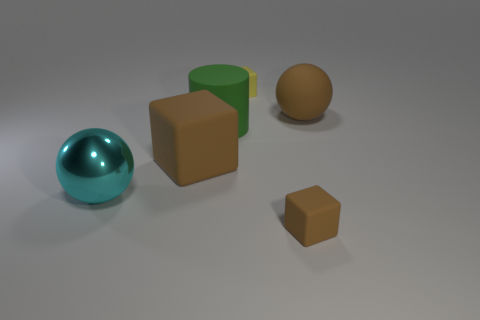What is the shape of the brown matte thing to the left of the tiny rubber cube that is behind the large sphere that is to the right of the tiny brown cube?
Provide a short and direct response. Cube. What number of things are big brown rubber objects to the left of the big green rubber cylinder or small cubes that are in front of the big cyan ball?
Provide a succinct answer. 2. There is a block that is behind the big brown rubber thing that is right of the large block; how big is it?
Your response must be concise. Small. Is the color of the big object to the right of the large cylinder the same as the large block?
Make the answer very short. Yes. Are there any gray shiny objects that have the same shape as the tiny yellow matte thing?
Offer a terse response. No. The metallic object that is the same size as the brown ball is what color?
Give a very brief answer. Cyan. What is the size of the sphere that is right of the big brown matte block?
Your response must be concise. Large. There is a brown block to the right of the small yellow block; are there any big spheres that are left of it?
Provide a short and direct response. Yes. Are the sphere on the right side of the large metal object and the tiny yellow cube made of the same material?
Give a very brief answer. Yes. How many things are behind the cyan metal ball and to the right of the large green matte cylinder?
Your answer should be very brief. 2. 